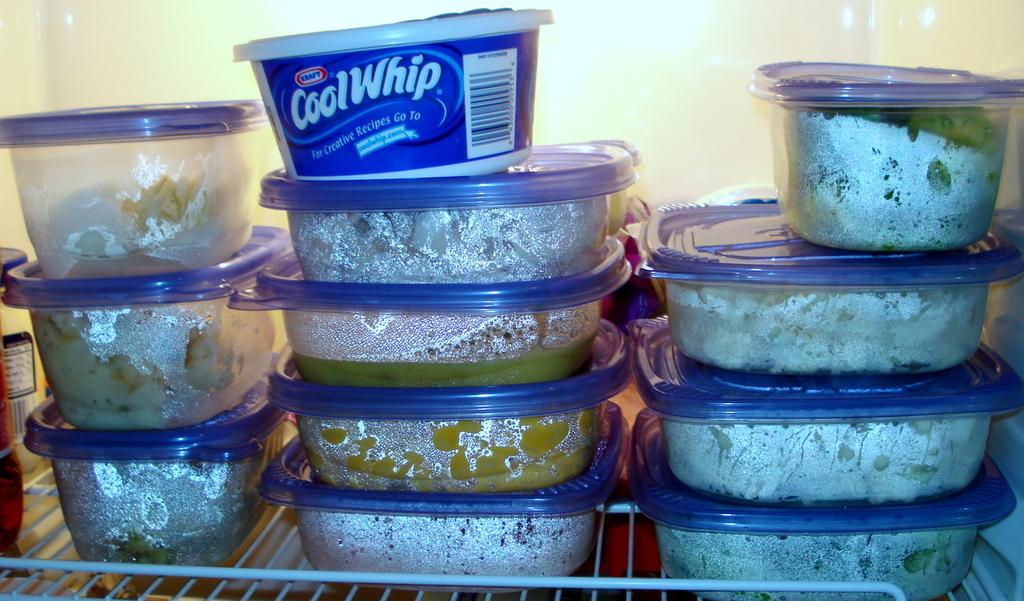What is the main object in the image? There is a fridge in the image. What is inside the fridge? The fridge contains many boxes on a rack. What type of education can be seen being provided to the donkey in the image? There is no donkey or education present in the image; it only features a fridge with boxes on a rack. 